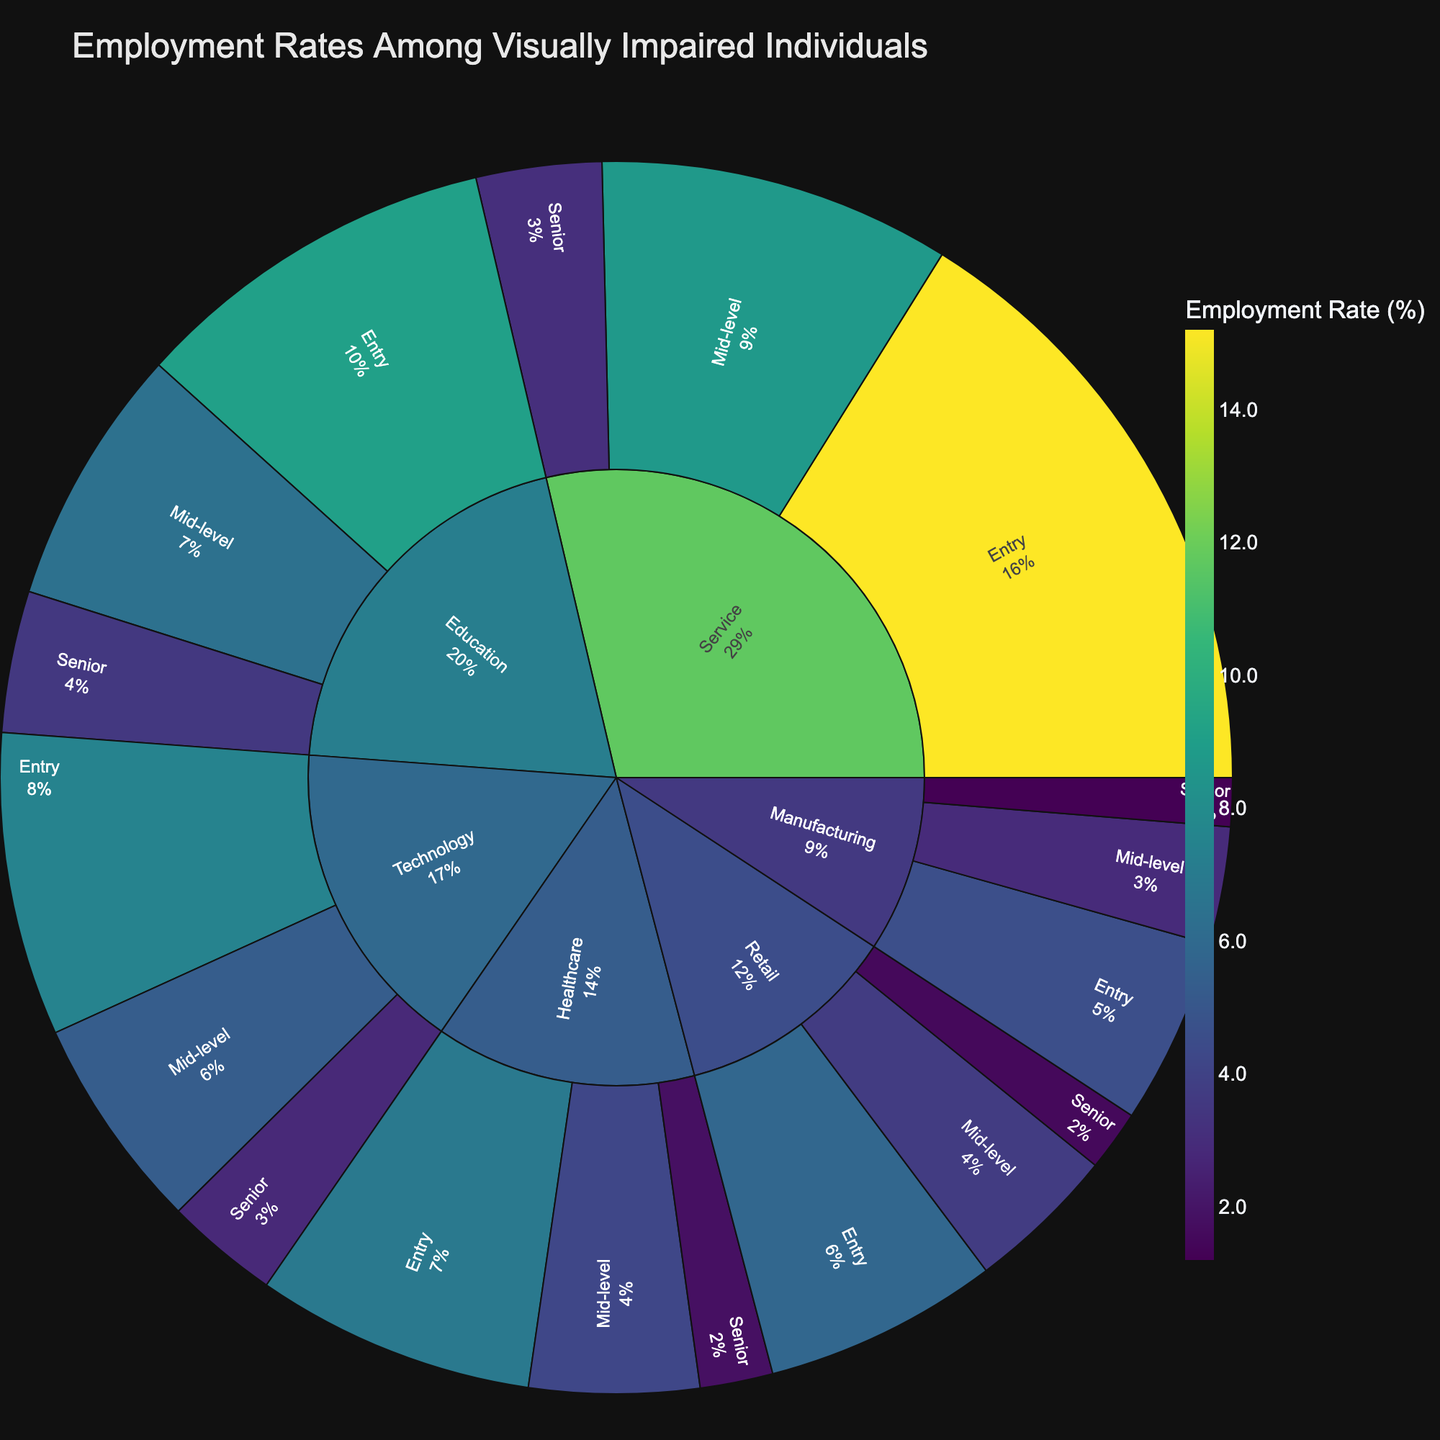What is the title of this sunburst plot? The title of a plot is usually displayed prominently at the top. In this case, it is "Employment Rates Among Visually Impaired Individuals".
Answer: Employment Rates Among Visually Impaired Individuals Which job level in the service industry has the highest employment rate? Look at the segments within the 'Service' industry in the plot. The largest segment indicates the highest employment rate, which is for 'Entry' level at 15.2%.
Answer: Entry level What is the combined employment rate for mid-level jobs across all industries? Add the employment rates for mid-level jobs in each industry: Service (8.7) + Technology (5.3) + Healthcare (4.2) + Education (6.4) + Manufacturing (2.9) + Retail (3.7). Summing these gives the total: 8.7 + 5.3 + 4.2 + 6.4 + 2.9 + 3.7 = 31.2.
Answer: 31.2% How does the employment rate for entry-level technology jobs compare to senior-level jobs in manufacturing? Compare the values for 'Entry' level in 'Technology' (7.5%) and 'Senior' level in 'Manufacturing' (1.2%). 7.5% is greater than 1.2%.
Answer: Entry-level technology is higher Which industry has the lowest senior-level employment rate? Look at the outermost segments representing senior levels across all industries. The smallest segment is ‘Manufacturing’ with a rate of 1.2%.
Answer: Manufacturing Between healthcare and education industries, which mid-level employment rate is higher? Look at the mid-level segments within 'Healthcare' (4.2%) and 'Education' (6.4%). The 'Education' mid-level employment rate is higher.
Answer: Education What is the ratio of entry-level employment rate in the service industry to the mid-level employment rate in the technology industry? Divide the employment rate of entry-level in ‘Service’ (15.2%) by mid-level in ‘Technology’ (5.3%): 15.2/5.3 ≈ 2.87.
Answer: Approximately 2.87 Which job level segment has the smallest representation in the sunburst plot? Identify the smallest segment in the plot. It is the 'Senior' level in 'Manufacturing' with an employment rate of 1.2%.
Answer: Senior level in Manufacturing What is the difference between the employment rates for entry-level jobs in healthcare and retail? Subtract the employment rate for entry-level jobs in 'Retail' (5.8%) from 'Healthcare' (6.9%): 6.9 - 5.8 = 1.1.
Answer: 1.1% In terms of the employment rate, which industry has the most evenly distributed job levels? Compare the sizes of the three job level segments within each industry. 'Technology' has the most balanced distribution with entry (7.5%), mid-level (5.3%), and senior (2.8%).
Answer: Technology 